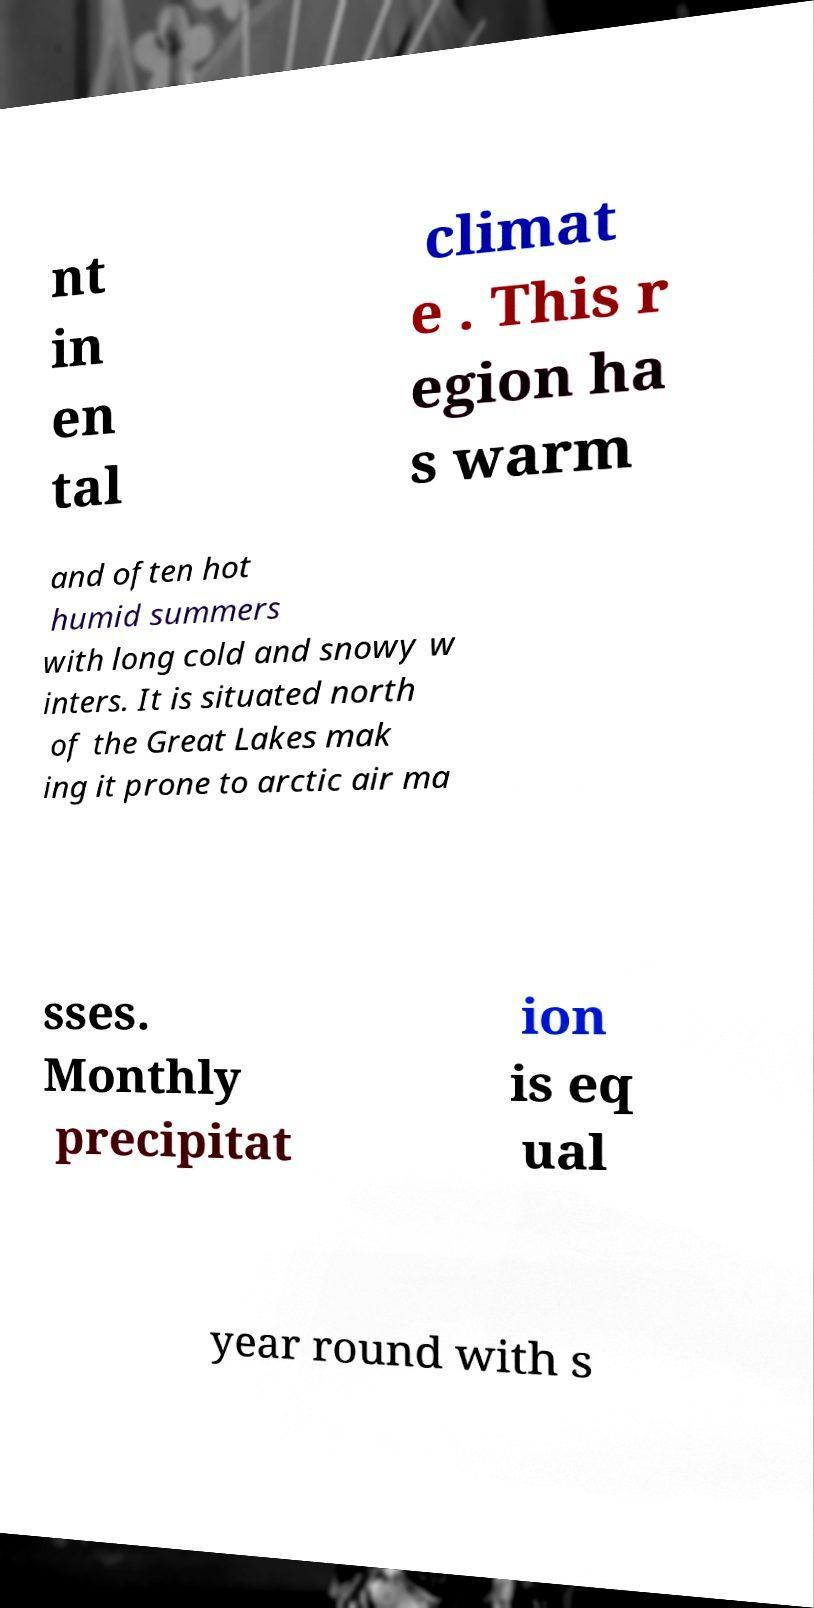I need the written content from this picture converted into text. Can you do that? nt in en tal climat e . This r egion ha s warm and often hot humid summers with long cold and snowy w inters. It is situated north of the Great Lakes mak ing it prone to arctic air ma sses. Monthly precipitat ion is eq ual year round with s 